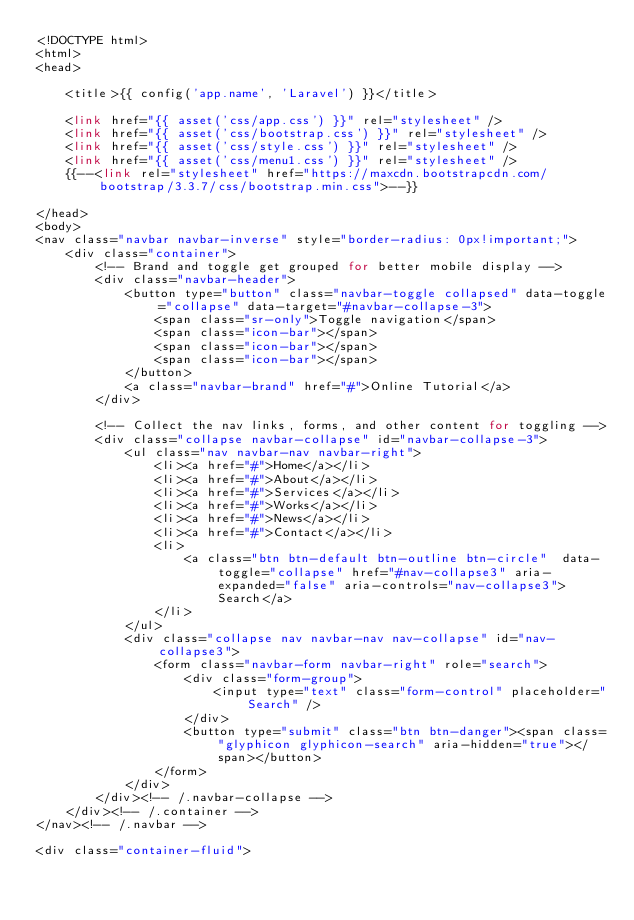Convert code to text. <code><loc_0><loc_0><loc_500><loc_500><_PHP_><!DOCTYPE html>
<html>
<head>

    <title>{{ config('app.name', 'Laravel') }}</title>

    <link href="{{ asset('css/app.css') }}" rel="stylesheet" />
    <link href="{{ asset('css/bootstrap.css') }}" rel="stylesheet" />
    <link href="{{ asset('css/style.css') }}" rel="stylesheet" />
    <link href="{{ asset('css/menu1.css') }}" rel="stylesheet" />
    {{--<link rel="stylesheet" href="https://maxcdn.bootstrapcdn.com/bootstrap/3.3.7/css/bootstrap.min.css">--}}

</head>
<body>
<nav class="navbar navbar-inverse" style="border-radius: 0px!important;">
    <div class="container">
        <!-- Brand and toggle get grouped for better mobile display -->
        <div class="navbar-header">
            <button type="button" class="navbar-toggle collapsed" data-toggle="collapse" data-target="#navbar-collapse-3">
                <span class="sr-only">Toggle navigation</span>
                <span class="icon-bar"></span>
                <span class="icon-bar"></span>
                <span class="icon-bar"></span>
            </button>
            <a class="navbar-brand" href="#">Online Tutorial</a>
        </div>

        <!-- Collect the nav links, forms, and other content for toggling -->
        <div class="collapse navbar-collapse" id="navbar-collapse-3">
            <ul class="nav navbar-nav navbar-right">
                <li><a href="#">Home</a></li>
                <li><a href="#">About</a></li>
                <li><a href="#">Services</a></li>
                <li><a href="#">Works</a></li>
                <li><a href="#">News</a></li>
                <li><a href="#">Contact</a></li>
                <li>
                    <a class="btn btn-default btn-outline btn-circle"  data-toggle="collapse" href="#nav-collapse3" aria-expanded="false" aria-controls="nav-collapse3">Search</a>
                </li>
            </ul>
            <div class="collapse nav navbar-nav nav-collapse" id="nav-collapse3">
                <form class="navbar-form navbar-right" role="search">
                    <div class="form-group">
                        <input type="text" class="form-control" placeholder="Search" />
                    </div>
                    <button type="submit" class="btn btn-danger"><span class="glyphicon glyphicon-search" aria-hidden="true"></span></button>
                </form>
            </div>
        </div><!-- /.navbar-collapse -->
    </div><!-- /.container -->
</nav><!-- /.navbar -->

<div class="container-fluid">
</code> 